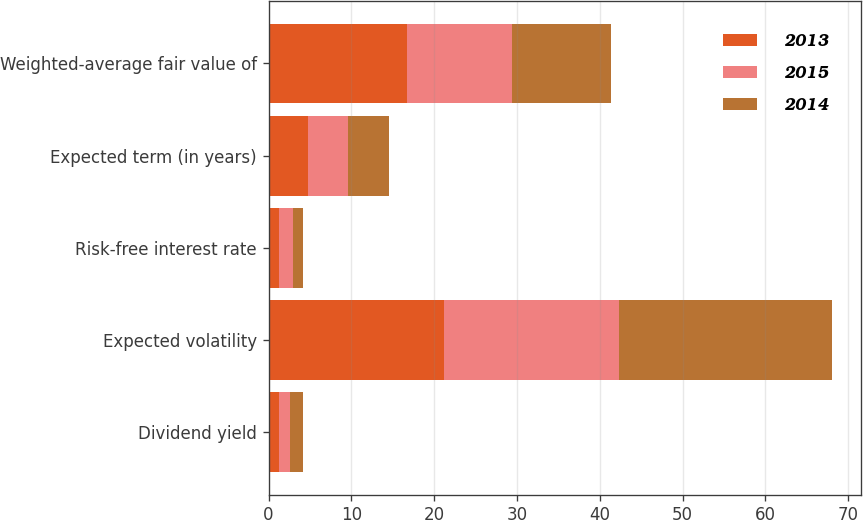Convert chart. <chart><loc_0><loc_0><loc_500><loc_500><stacked_bar_chart><ecel><fcel>Dividend yield<fcel>Expected volatility<fcel>Risk-free interest rate<fcel>Expected term (in years)<fcel>Weighted-average fair value of<nl><fcel>2013<fcel>1.2<fcel>21.2<fcel>1.3<fcel>4.8<fcel>16.75<nl><fcel>2015<fcel>1.4<fcel>21.1<fcel>1.6<fcel>4.8<fcel>12.63<nl><fcel>2014<fcel>1.5<fcel>25.8<fcel>1.3<fcel>4.9<fcel>11.95<nl></chart> 